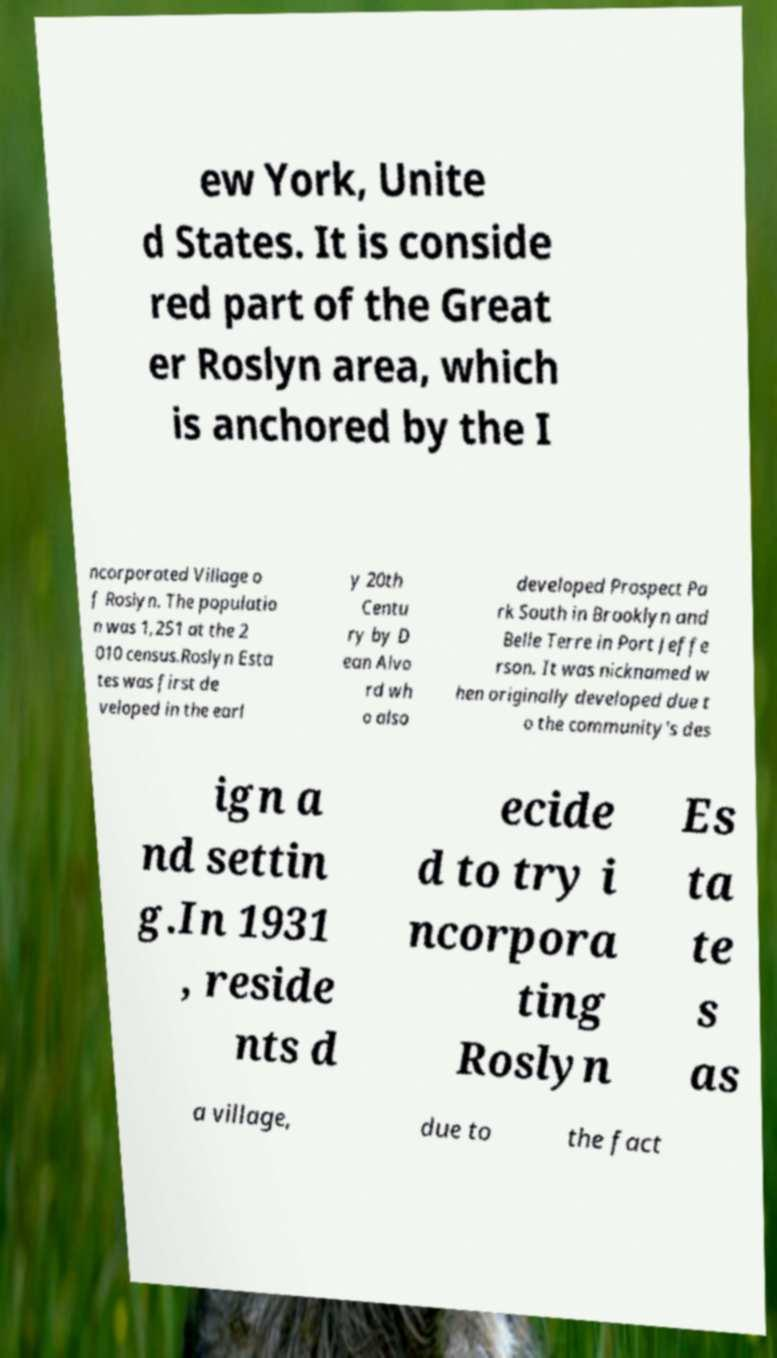I need the written content from this picture converted into text. Can you do that? ew York, Unite d States. It is conside red part of the Great er Roslyn area, which is anchored by the I ncorporated Village o f Roslyn. The populatio n was 1,251 at the 2 010 census.Roslyn Esta tes was first de veloped in the earl y 20th Centu ry by D ean Alvo rd wh o also developed Prospect Pa rk South in Brooklyn and Belle Terre in Port Jeffe rson. It was nicknamed w hen originally developed due t o the community's des ign a nd settin g.In 1931 , reside nts d ecide d to try i ncorpora ting Roslyn Es ta te s as a village, due to the fact 